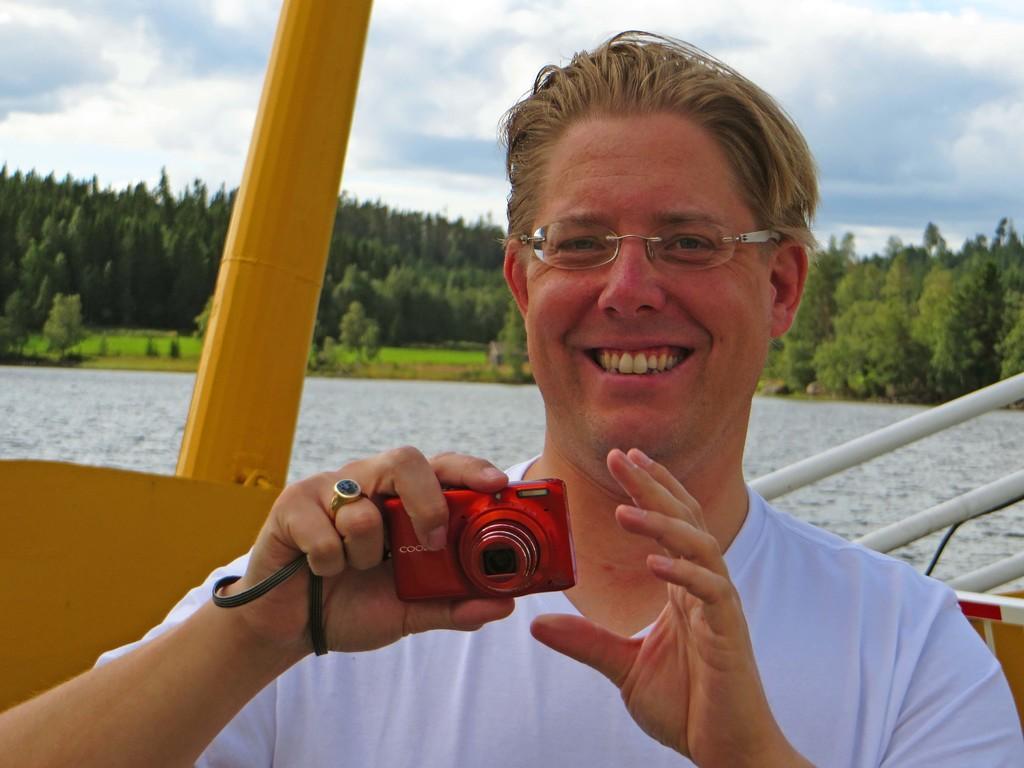How would you summarize this image in a sentence or two? a person is holding a red color camera in his hand. behind him there is water and trees. 